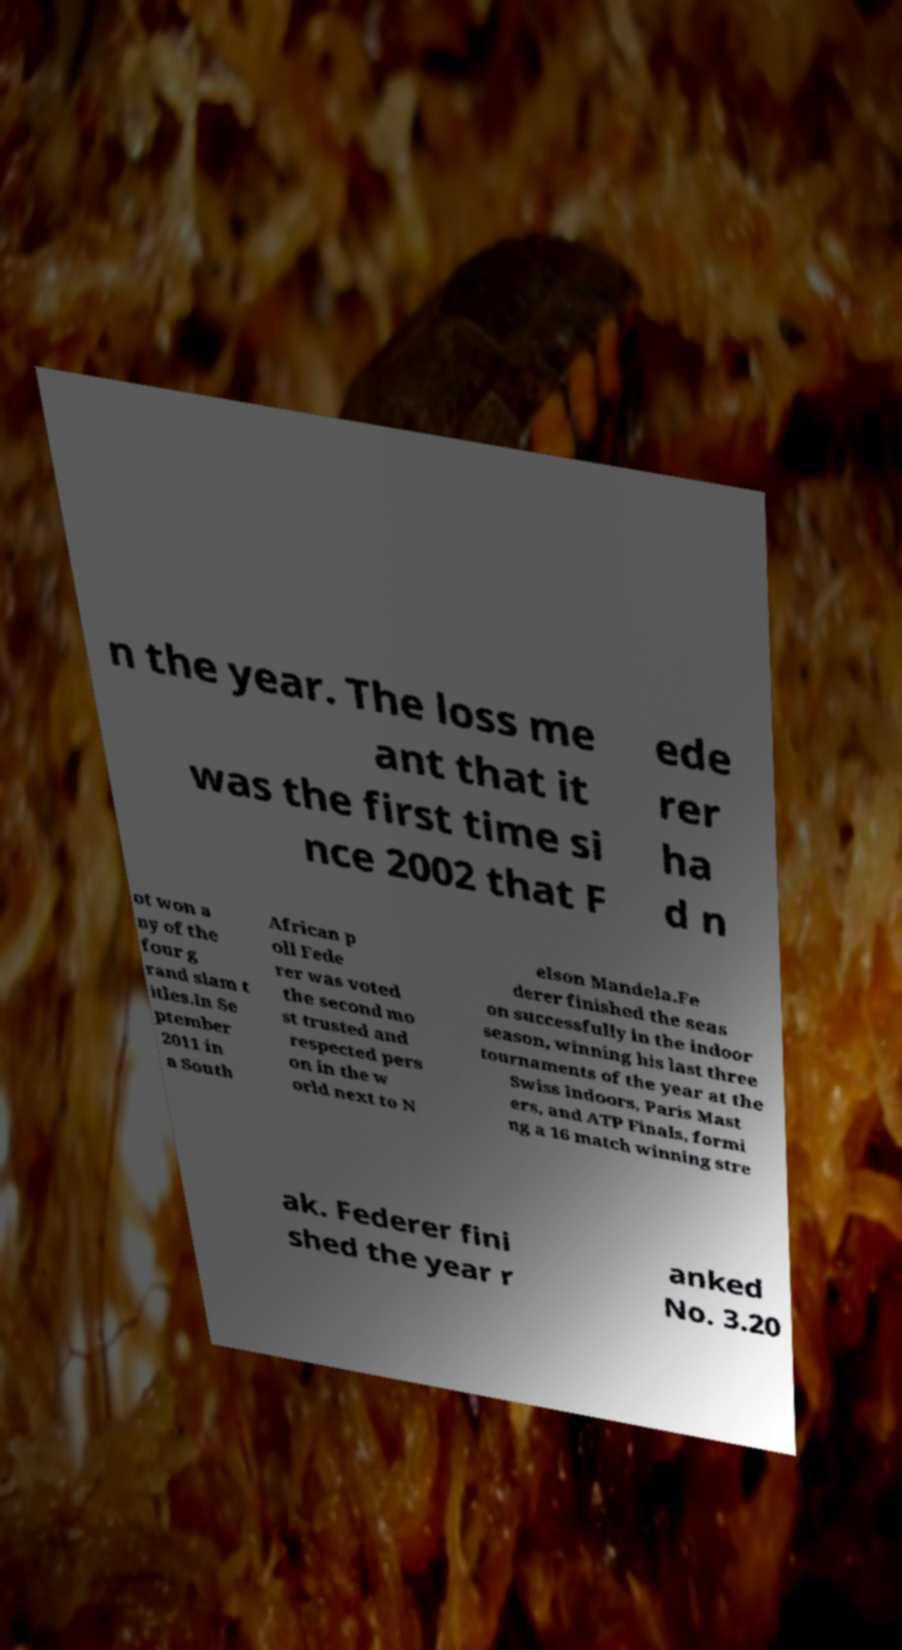Please identify and transcribe the text found in this image. n the year. The loss me ant that it was the first time si nce 2002 that F ede rer ha d n ot won a ny of the four g rand slam t itles.In Se ptember 2011 in a South African p oll Fede rer was voted the second mo st trusted and respected pers on in the w orld next to N elson Mandela.Fe derer finished the seas on successfully in the indoor season, winning his last three tournaments of the year at the Swiss Indoors, Paris Mast ers, and ATP Finals, formi ng a 16 match winning stre ak. Federer fini shed the year r anked No. 3.20 